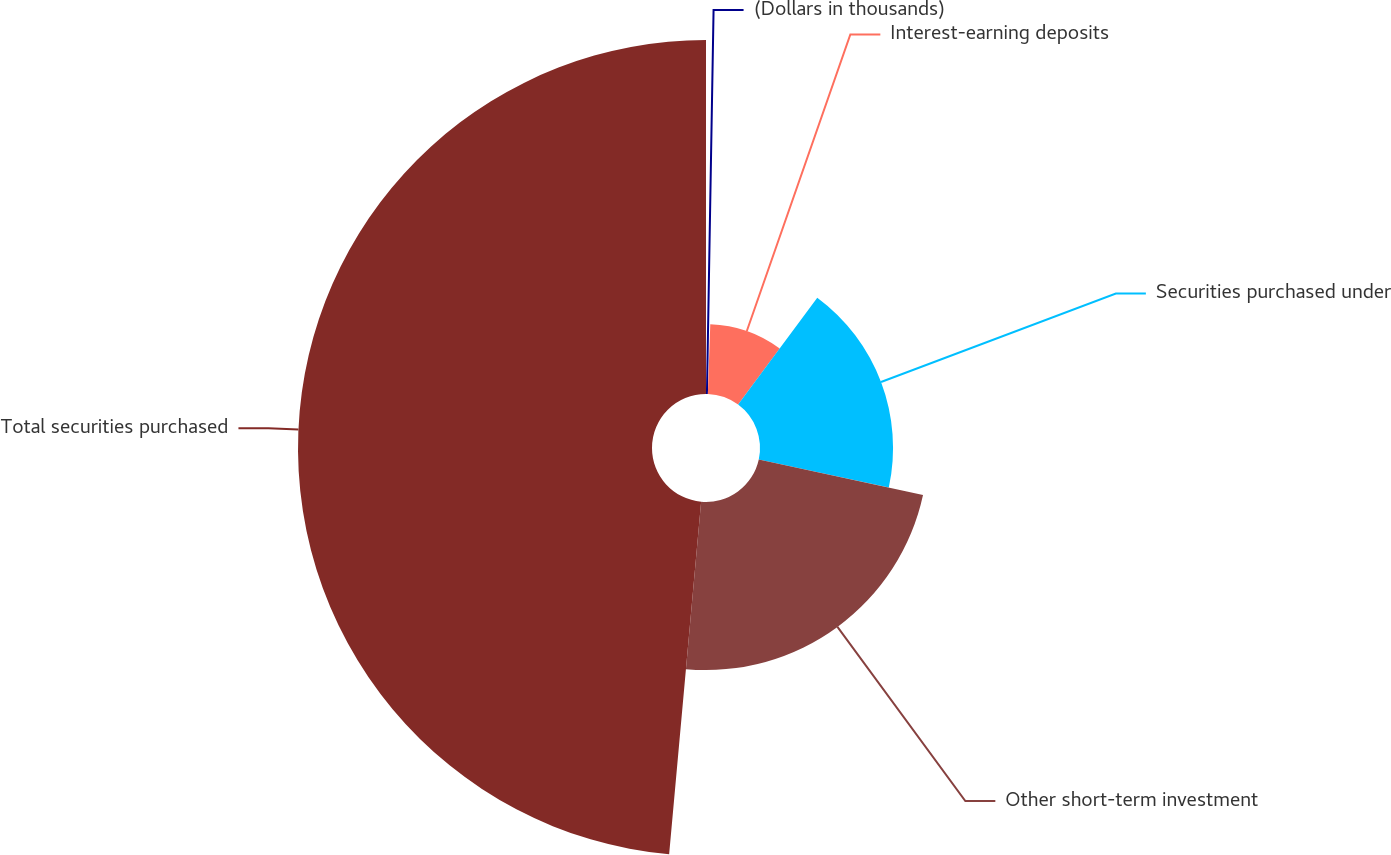<chart> <loc_0><loc_0><loc_500><loc_500><pie_chart><fcel>(Dollars in thousands)<fcel>Interest-earning deposits<fcel>Securities purchased under<fcel>Other short-term investment<fcel>Total securities purchased<nl><fcel>0.55%<fcel>9.59%<fcel>18.25%<fcel>23.05%<fcel>48.56%<nl></chart> 